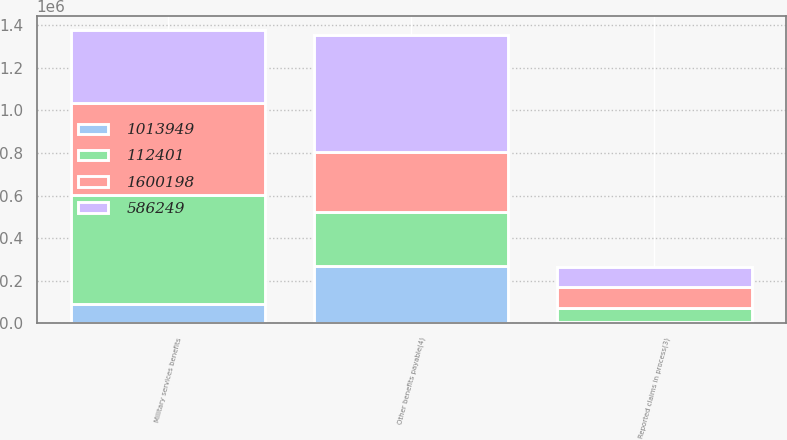Convert chart to OTSL. <chart><loc_0><loc_0><loc_500><loc_500><stacked_bar_chart><ecel><fcel>Military services benefits<fcel>Reported claims in process(3)<fcel>Other benefits payable(4)<nl><fcel>586249<fcel>341372<fcel>91938<fcel>550924<nl><fcel>1.6002e+06<fcel>430674<fcel>98033<fcel>281502<nl><fcel>112401<fcel>514426<fcel>67065<fcel>253702<nl><fcel>1.01395e+06<fcel>89302<fcel>6095<fcel>269422<nl></chart> 